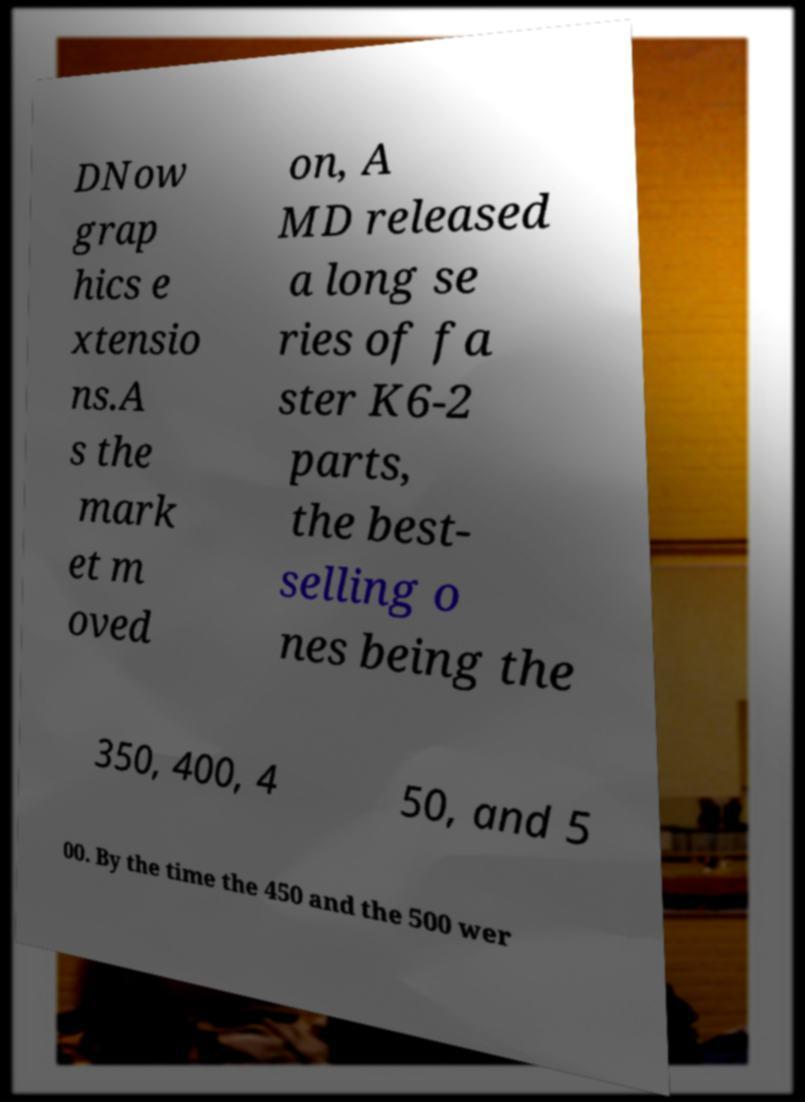For documentation purposes, I need the text within this image transcribed. Could you provide that? DNow grap hics e xtensio ns.A s the mark et m oved on, A MD released a long se ries of fa ster K6-2 parts, the best- selling o nes being the 350, 400, 4 50, and 5 00. By the time the 450 and the 500 wer 